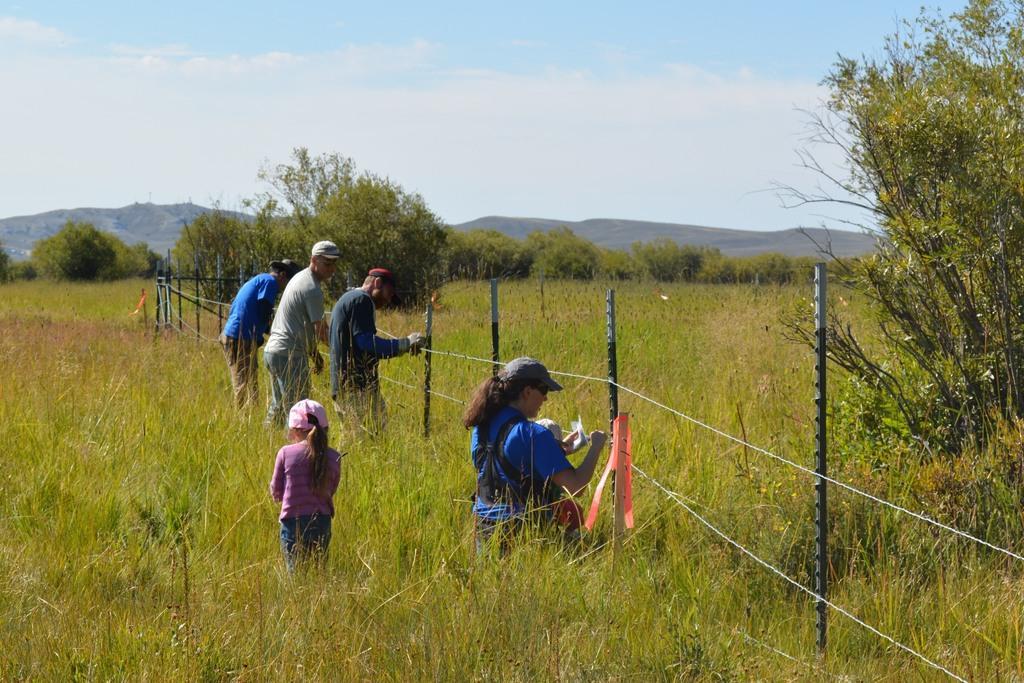Please provide a concise description of this image. In this image we can see few people wearing caps. On the ground there is grass. Also there is a fencing with poles and ropes. Also there are trees. In the background there are trees. Also there are hills and there is sky with clouds. 